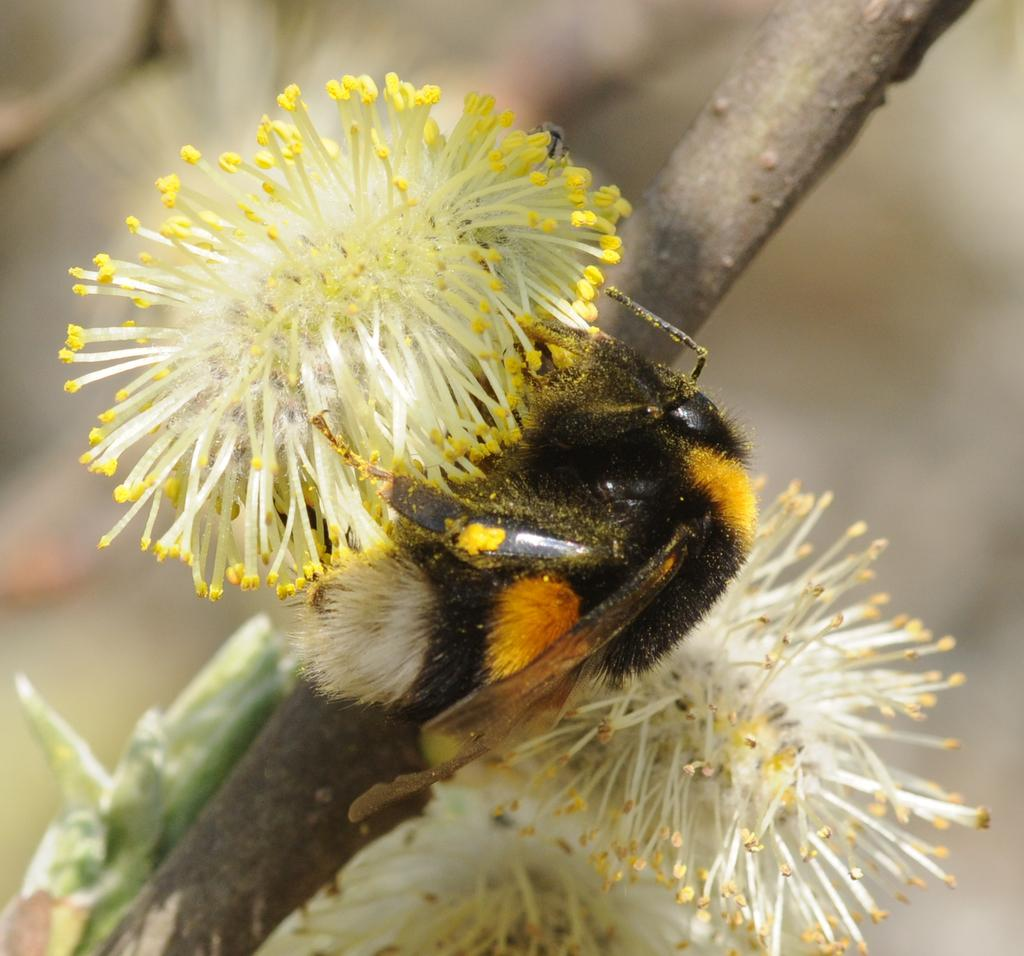What is on the branch of the tree in the image? There is a flower and an insect on the branch of the tree in the image. Can you describe the flower on the branch? The facts provided do not give a detailed description of the flower. What type of insect is on the branch? The facts provided do not specify the type of insect on the branch. How does the fireman put out the cracker in the image? There is no fireman or cracker present in the image. 